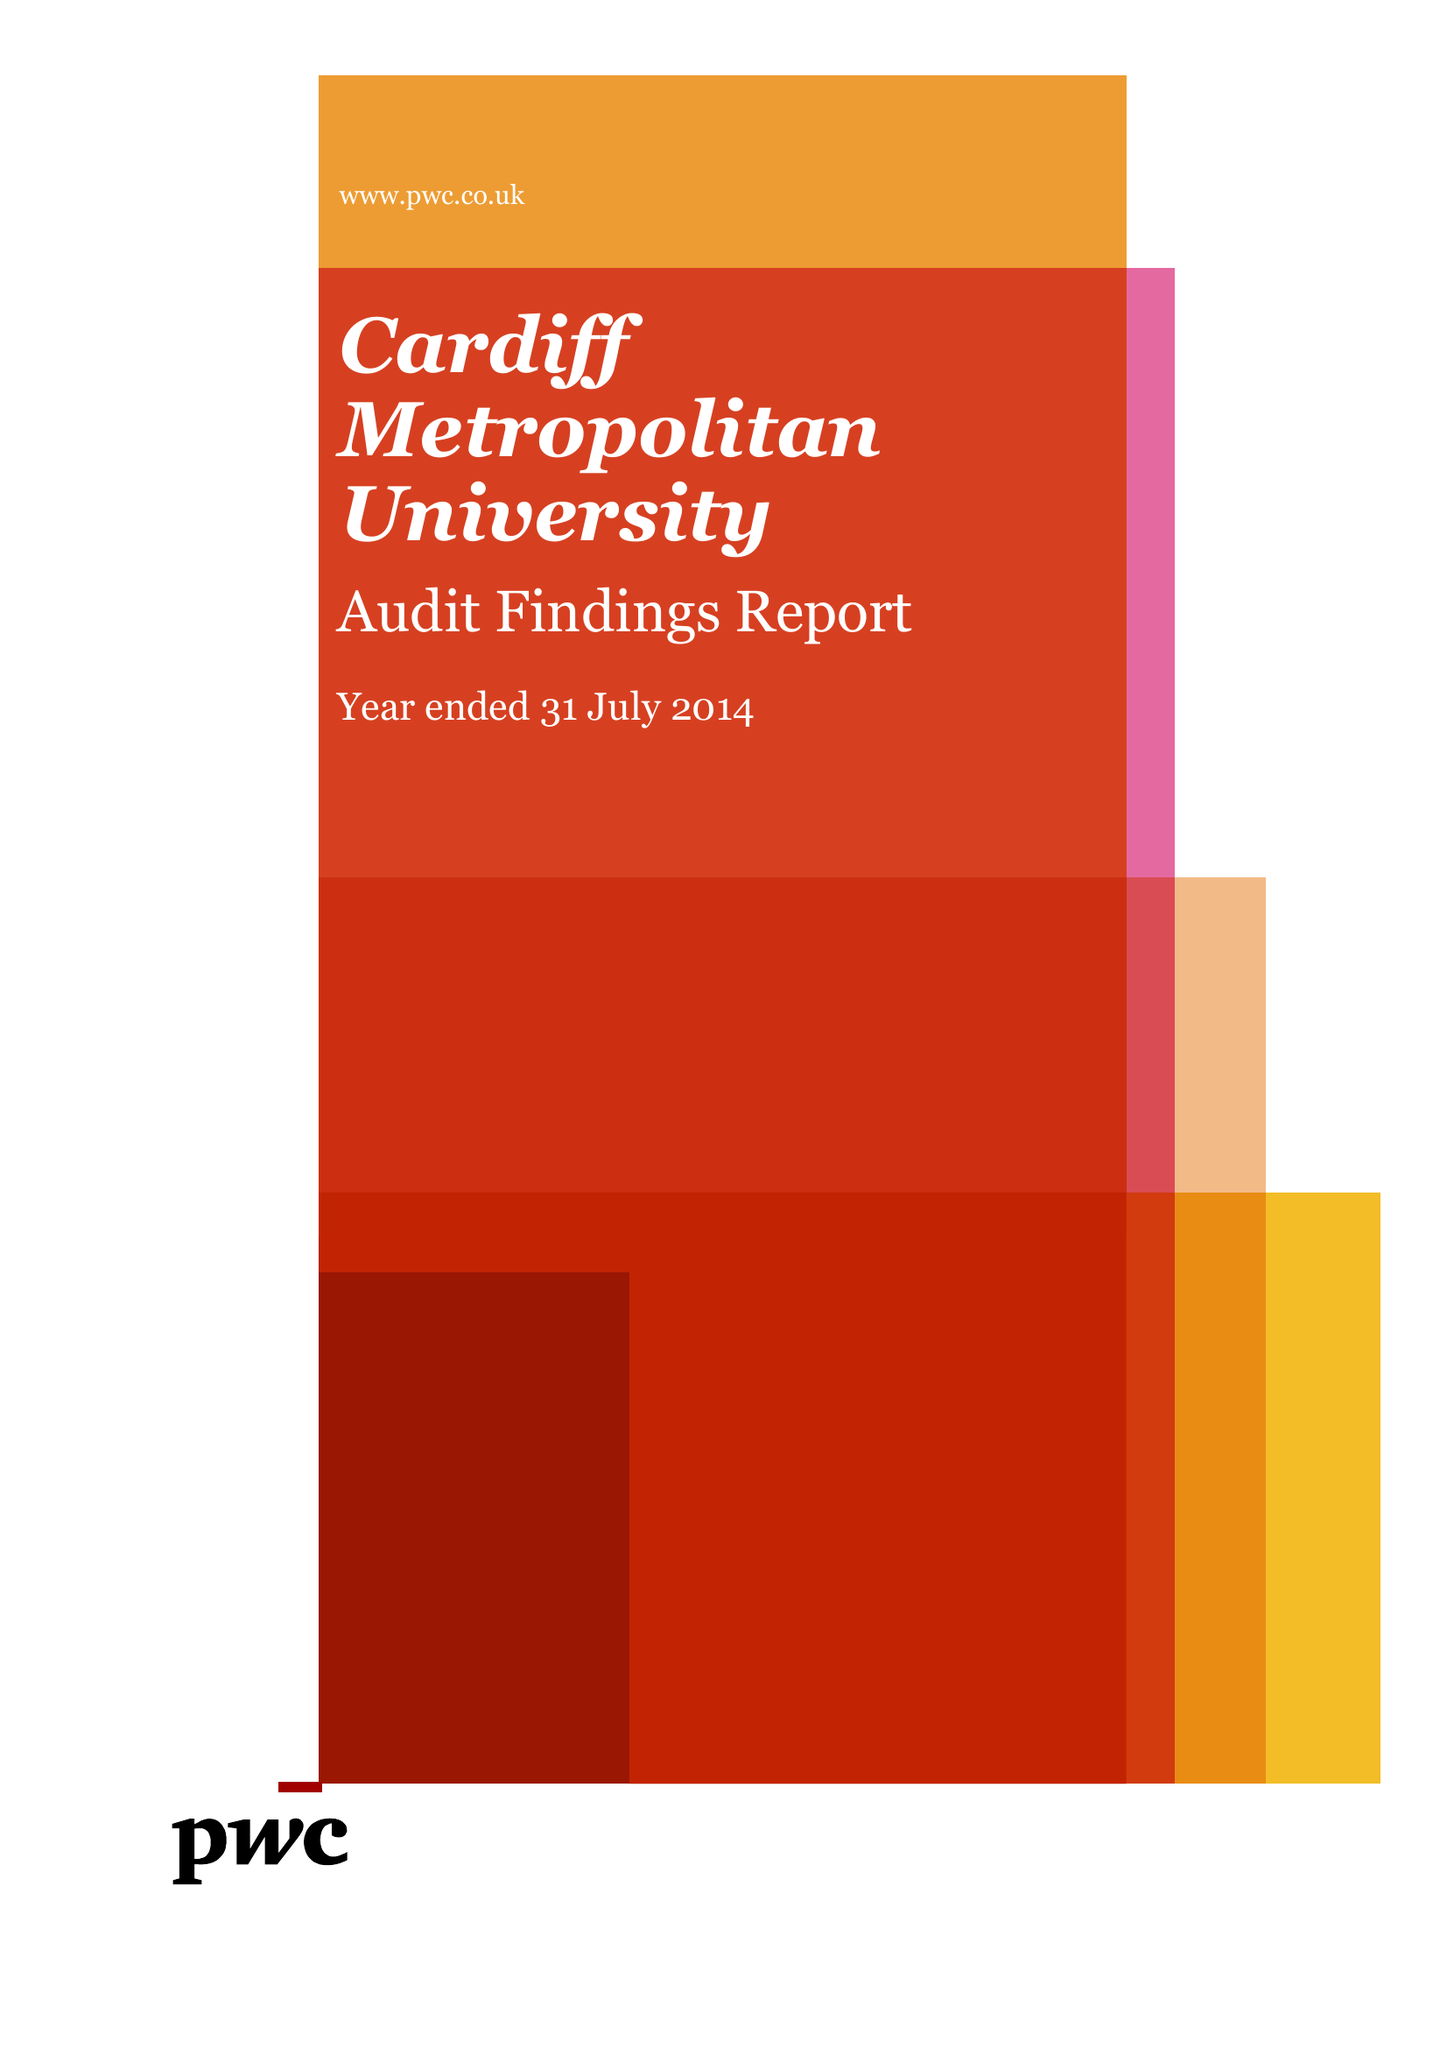What is the value for the address__post_town?
Answer the question using a single word or phrase. CARDIFF 